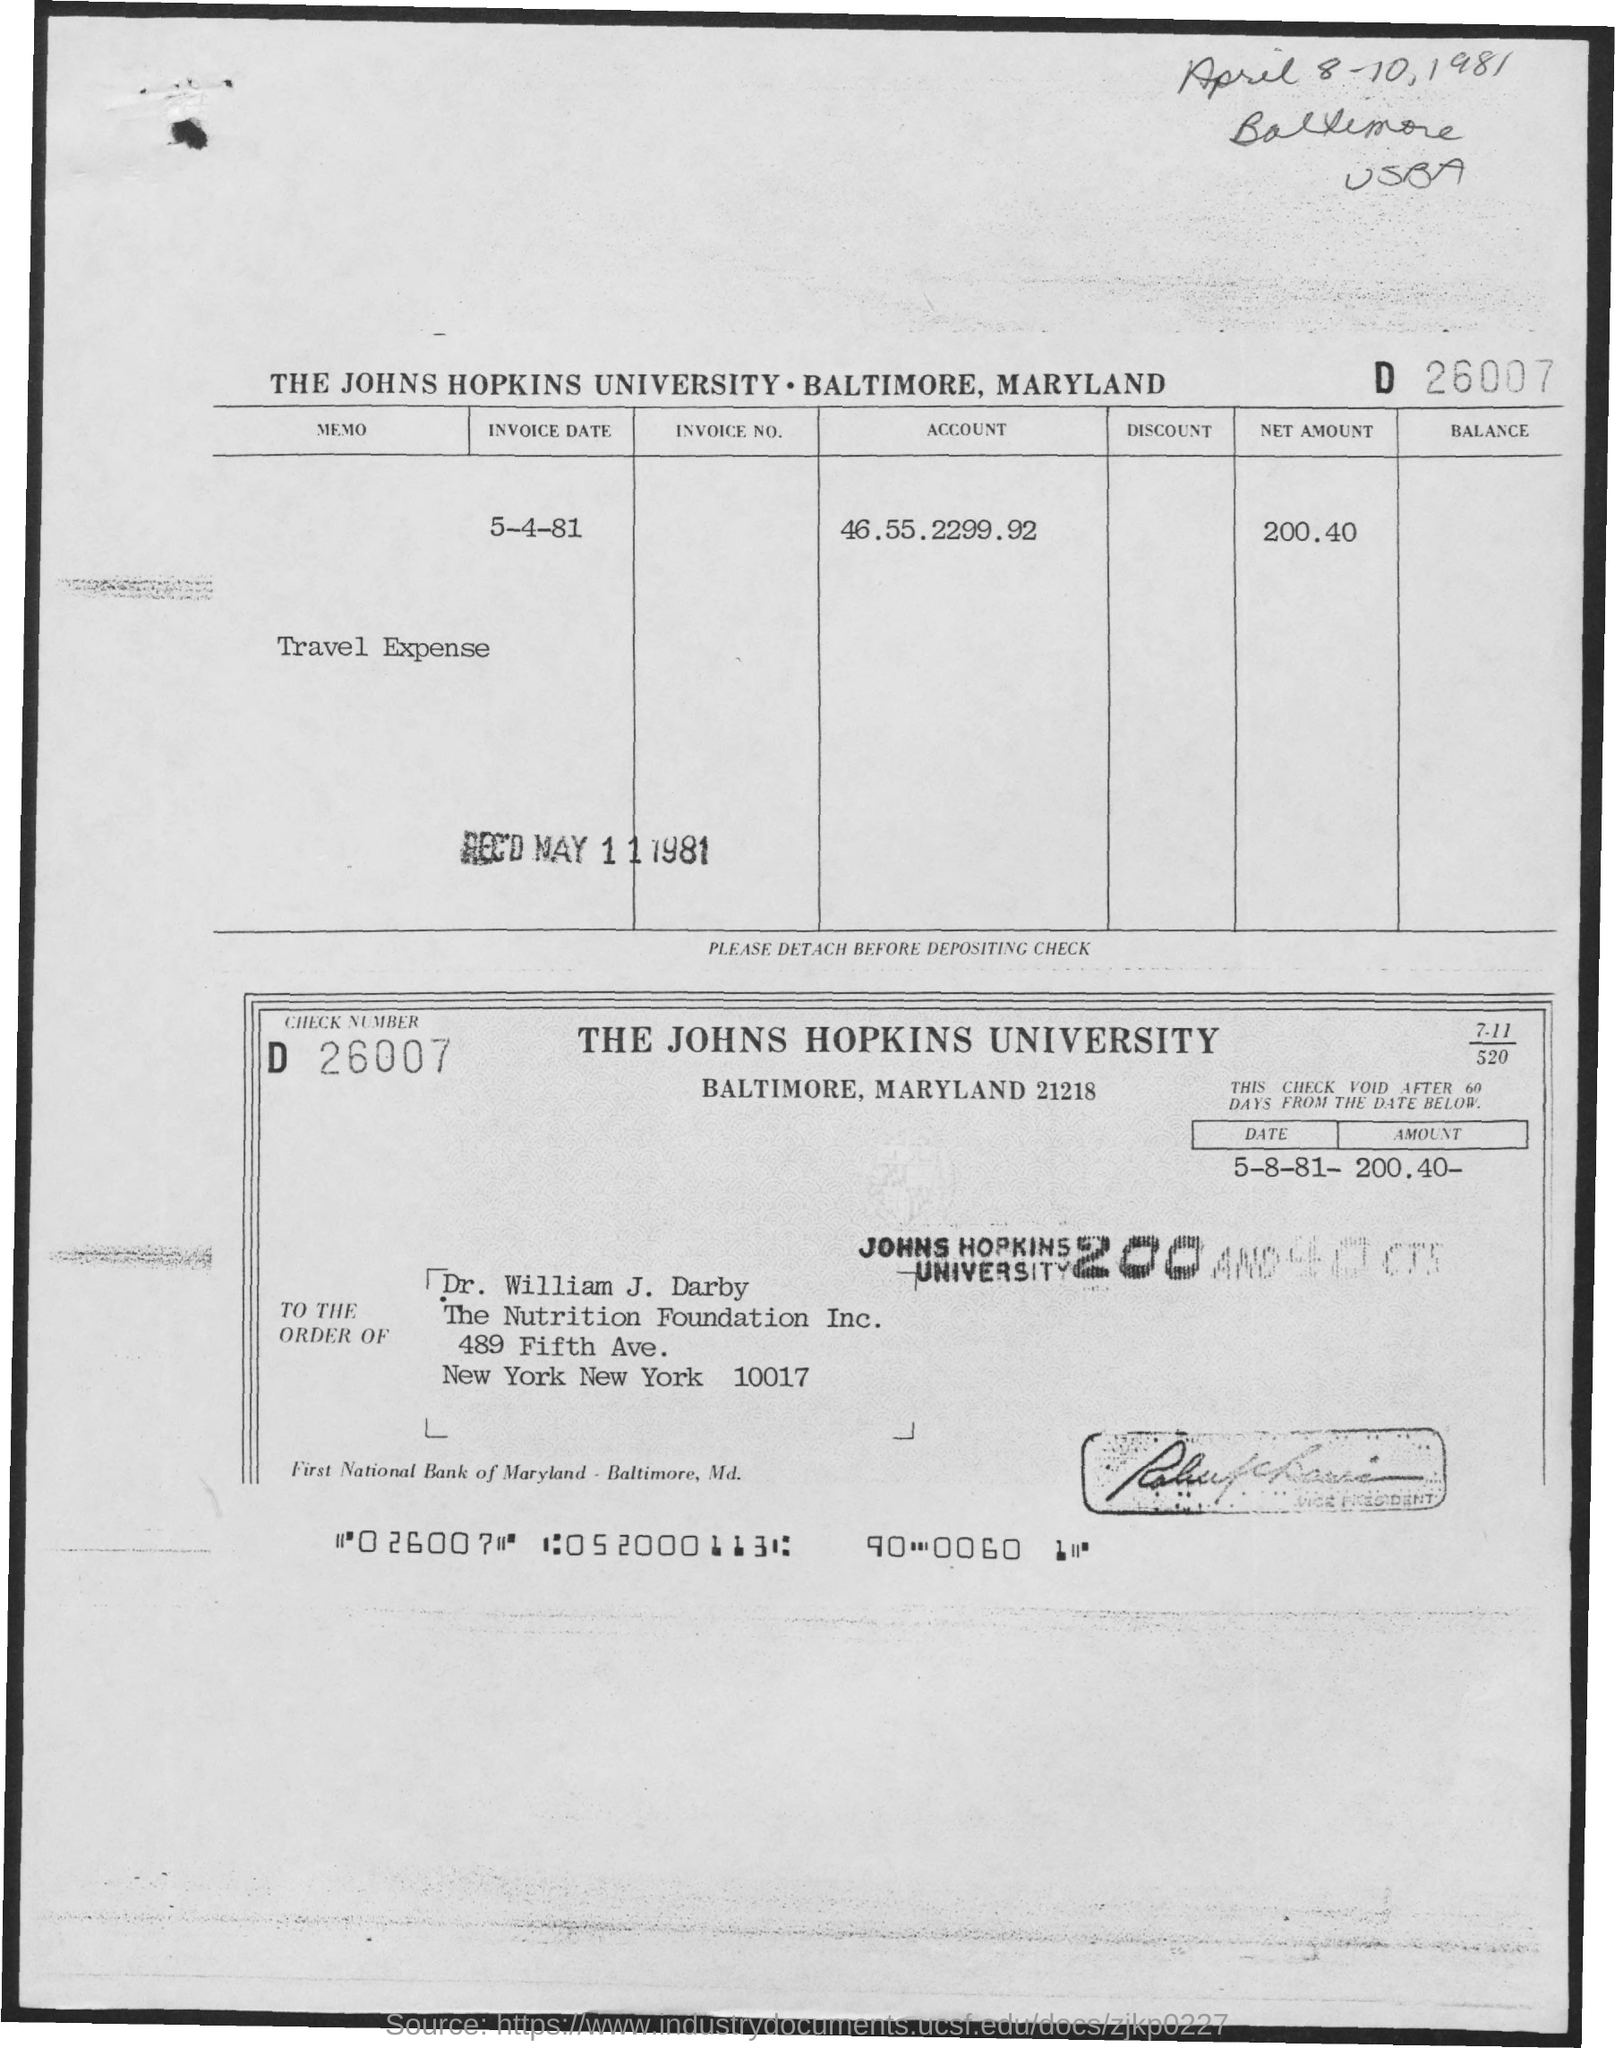What is the Invoice date ?
Your answer should be very brief. 5-4-81. What is the Account Number ?
Your answer should be very brief. 46.55.2299.92. How much net amount ?
Provide a succinct answer. 200.40. 